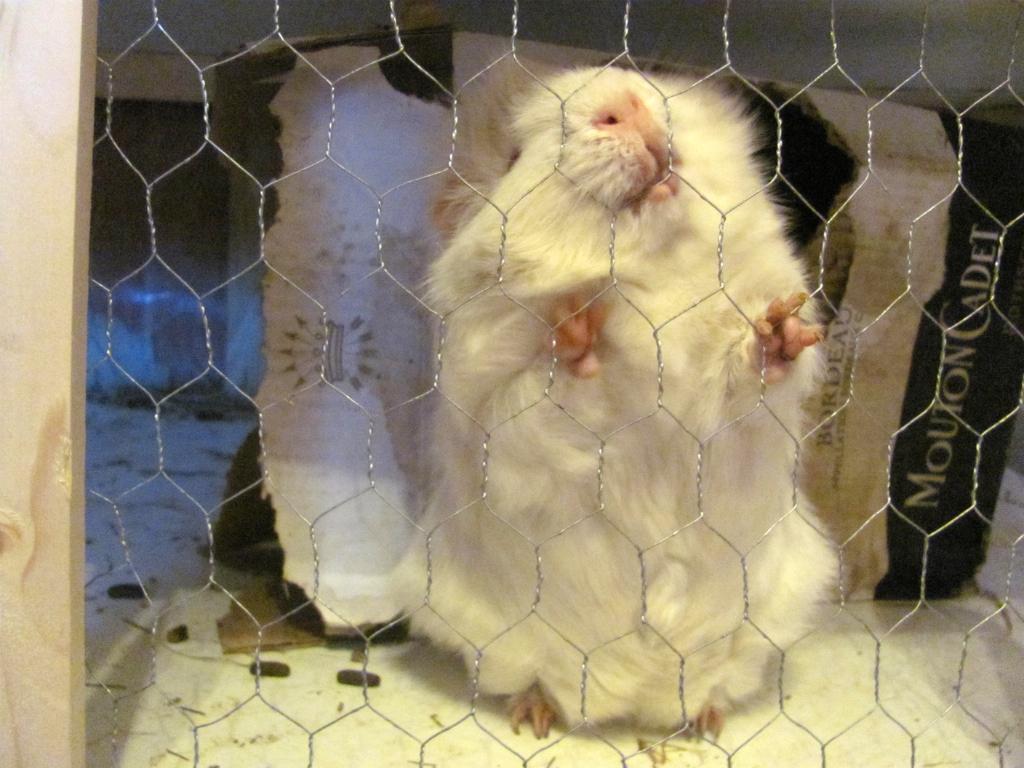How would you summarize this image in a sentence or two? In this picture I can see there is a rat inside the cage which is made of wooden frame and in the backdrop there is a cardboard. 